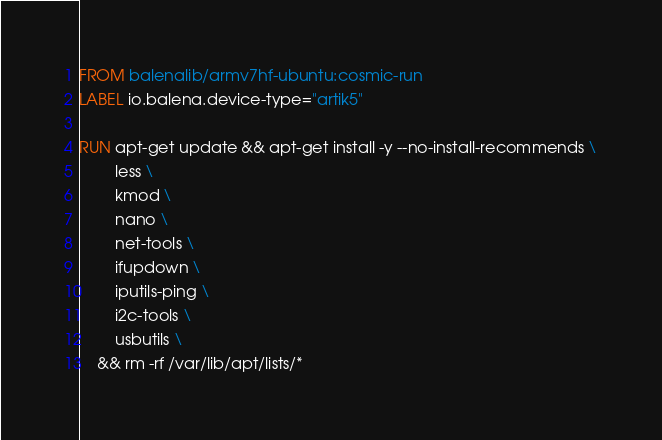<code> <loc_0><loc_0><loc_500><loc_500><_Dockerfile_>FROM balenalib/armv7hf-ubuntu:cosmic-run
LABEL io.balena.device-type="artik5"

RUN apt-get update && apt-get install -y --no-install-recommends \
		less \
		kmod \
		nano \
		net-tools \
		ifupdown \
		iputils-ping \
		i2c-tools \
		usbutils \
	&& rm -rf /var/lib/apt/lists/*</code> 